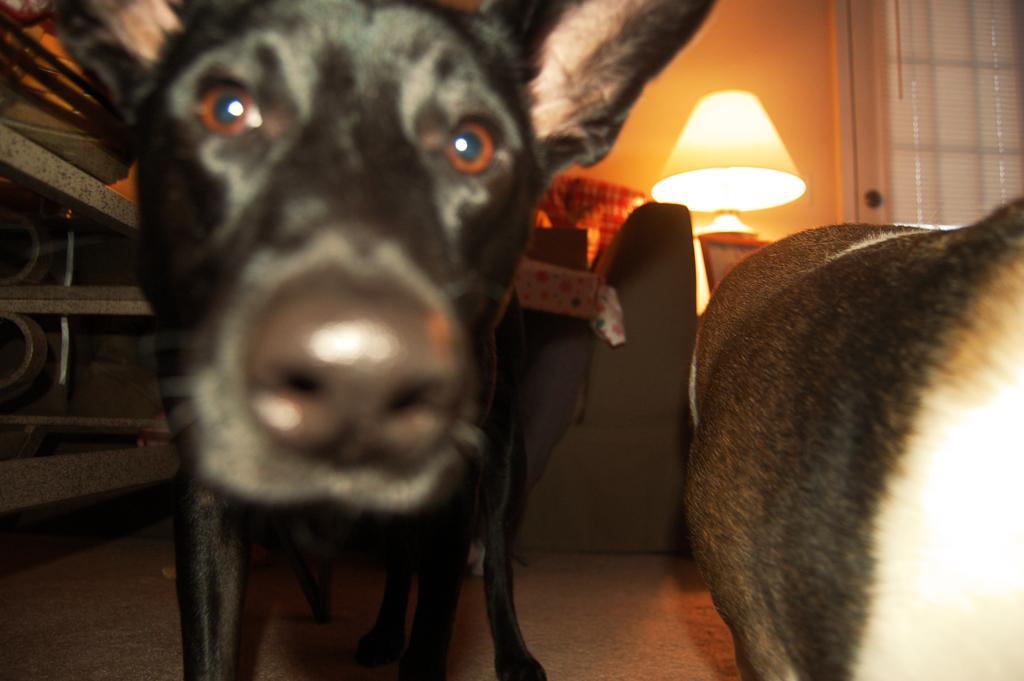In one or two sentences, can you explain what this image depicts? At the foreground of the image we can see a face of dog which is in black color and the body of a dog which is in brown color and at the background of the image there is couch, lamp, window and curtain. 